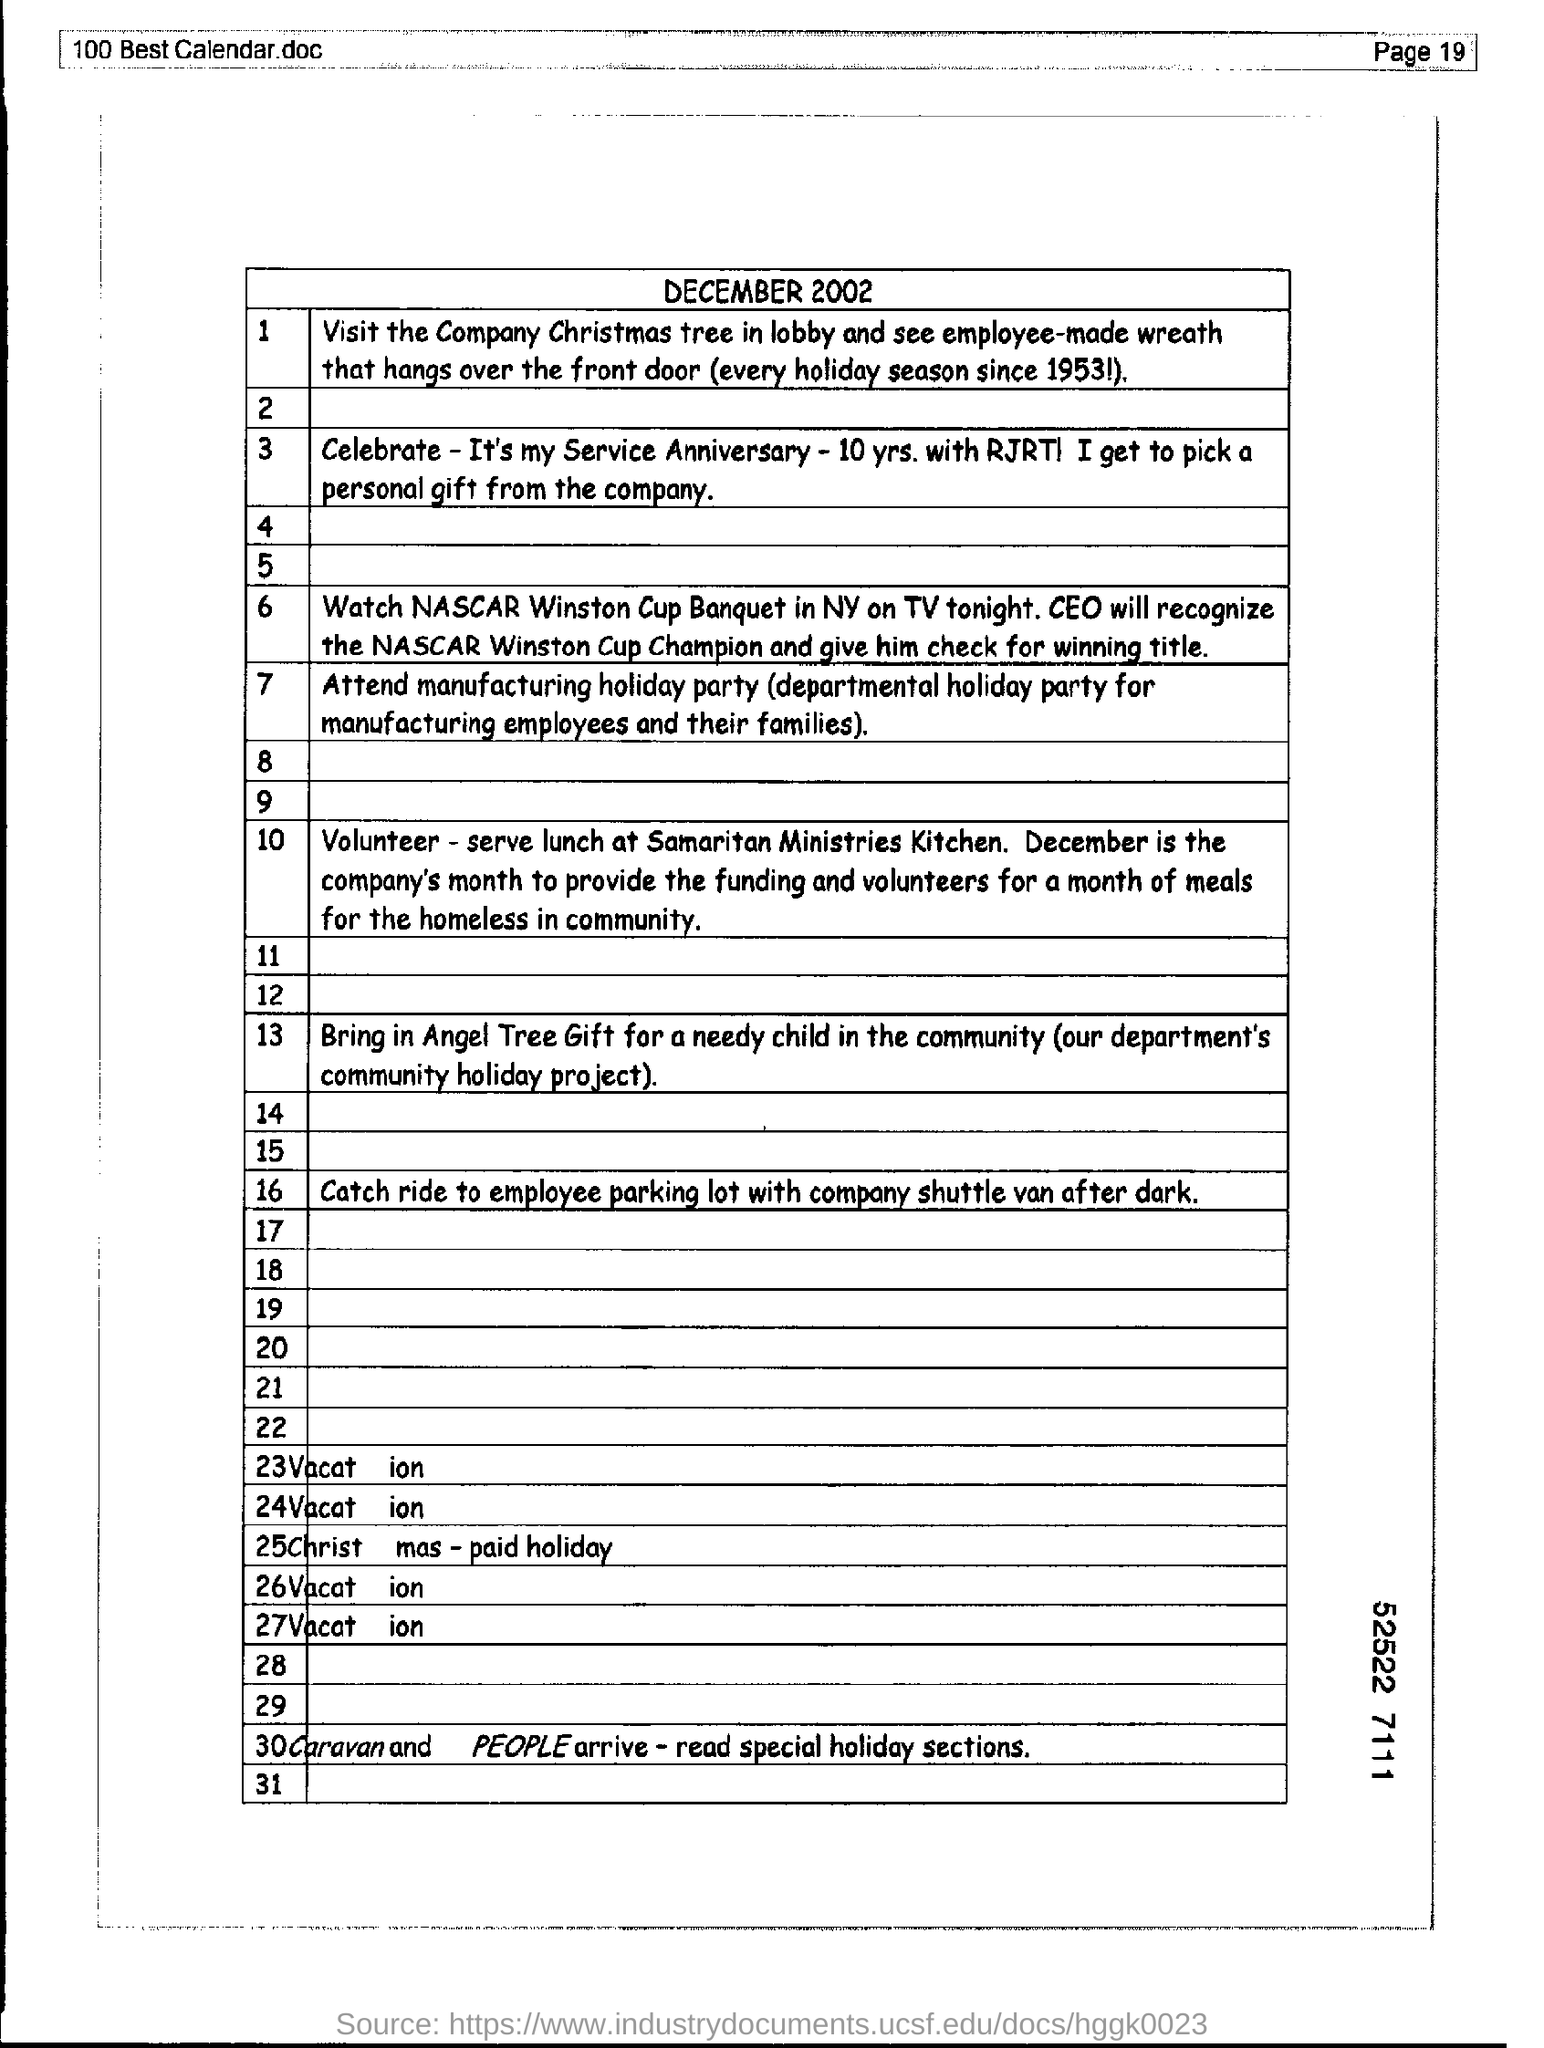Mention the page number at top right corner of the page ?
Give a very brief answer. Page 19. 